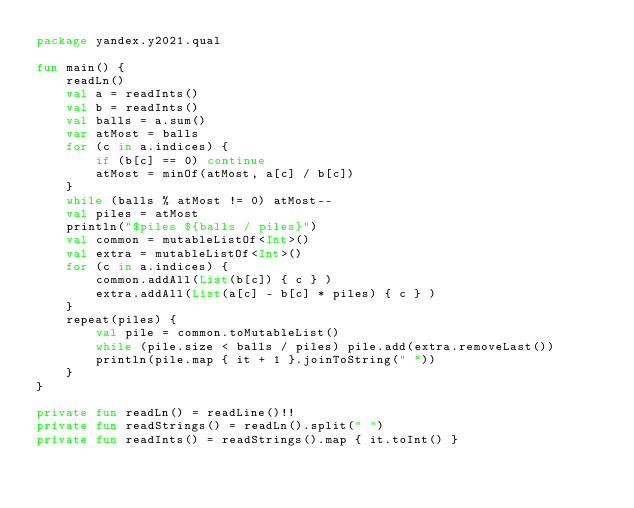Convert code to text. <code><loc_0><loc_0><loc_500><loc_500><_Kotlin_>package yandex.y2021.qual

fun main() {
	readLn()
	val a = readInts()
	val b = readInts()
	val balls = a.sum()
	var atMost = balls
	for (c in a.indices) {
		if (b[c] == 0) continue
		atMost = minOf(atMost, a[c] / b[c])
	}
	while (balls % atMost != 0) atMost--
	val piles = atMost
	println("$piles ${balls / piles}")
	val common = mutableListOf<Int>()
	val extra = mutableListOf<Int>()
	for (c in a.indices) {
		common.addAll(List(b[c]) { c } )
		extra.addAll(List(a[c] - b[c] * piles) { c } )
	}
	repeat(piles) {
		val pile = common.toMutableList()
		while (pile.size < balls / piles) pile.add(extra.removeLast())
		println(pile.map { it + 1 }.joinToString(" "))
	}
}

private fun readLn() = readLine()!!
private fun readStrings() = readLn().split(" ")
private fun readInts() = readStrings().map { it.toInt() }
</code> 